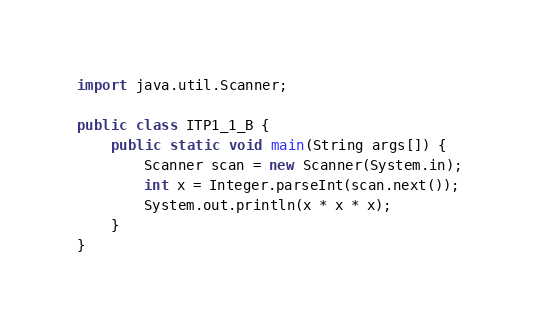Convert code to text. <code><loc_0><loc_0><loc_500><loc_500><_Java_>
import java.util.Scanner;

public class ITP1_1_B {
    public static void main(String args[]) {
        Scanner scan = new Scanner(System.in);
        int x = Integer.parseInt(scan.next());
        System.out.println(x * x * x);
    }
}</code> 